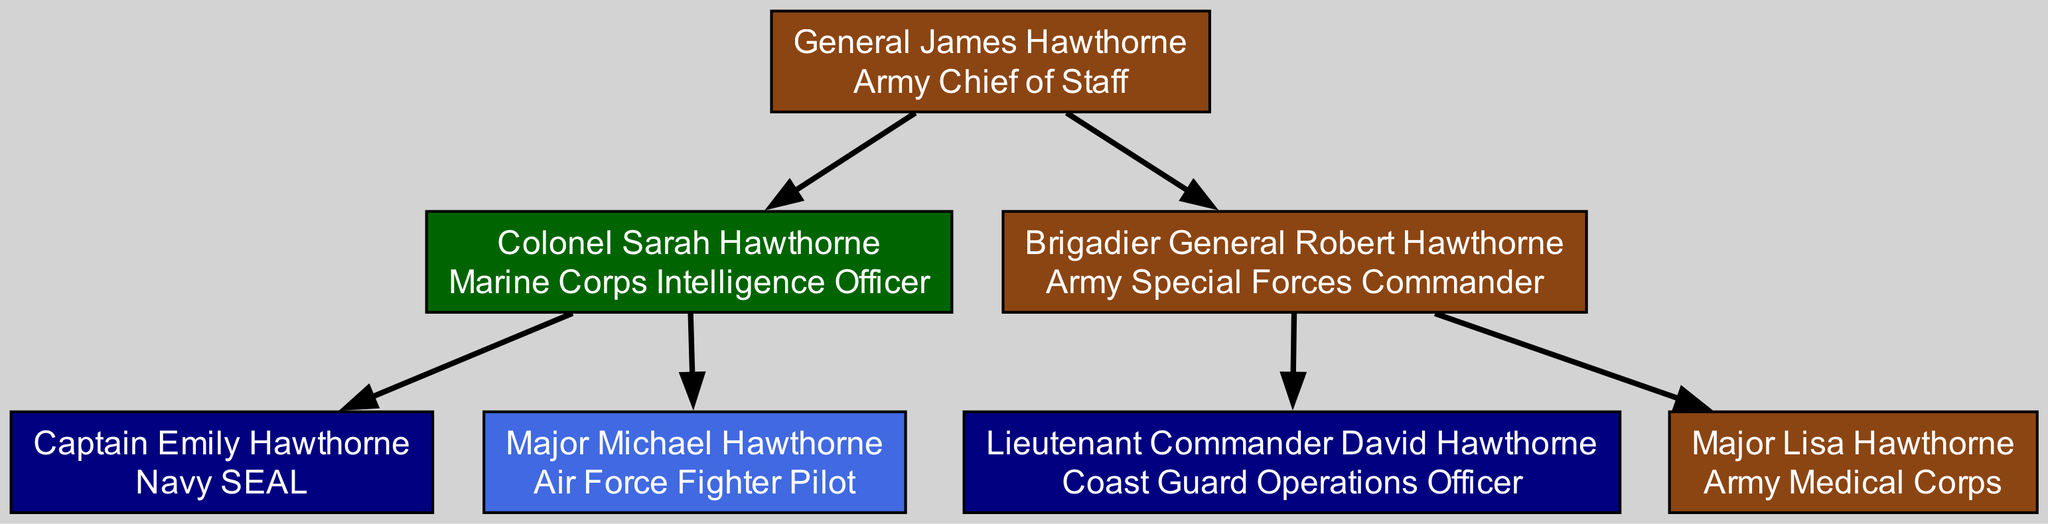What is the role of General James Hawthorne? According to the diagram, General James Hawthorne is designated as the Army Chief of Staff. This is found directly under his name in the root node of the family tree.
Answer: Army Chief of Staff Who is the eldest child of General James Hawthorne? The eldest child listed under General James Hawthorne is Colonel Sarah Hawthorne, as she is the first node in the children array.
Answer: Colonel Sarah Hawthorne How many grandchildren does General James Hawthorne have? There are a total of four grandchildren mentioned under the children of Colonel Sarah Hawthorne and Brigadier General Robert Hawthorne, counted as Captain Emily Hawthorne, Major Michael Hawthorne, Lieutenant Commander David Hawthorne, and Major Lisa Hawthorne.
Answer: Four What military branch does Major Lisa Hawthorne serve in? Major Lisa Hawthorne is associated with the Army Medical Corps, which is part of the Army branch indicated in her role description.
Answer: Army Which branch has more members, the Army or the Navy? In the diagram, there are three Army members (General James, Colonel Sarah, Brigadier General Robert, and Major Lisa) and two Navy members (Captain Emily and Lieutenant Commander David) as per their roles, indicating that the Army has more members.
Answer: Army What is the role of Captain Emily Hawthorne? Captain Emily Hawthorne is specifically noted as a Navy SEAL in the diagram, which is her distinct role associated with the Navy branch.
Answer: Navy SEAL Which of General James Hawthorne's children is a Marine Corps officer? The diagram indicates that Colonel Sarah Hawthorne serves as a Marine Corps Intelligence Officer, which is identified directly under her name.
Answer: Colonel Sarah Hawthorne How many total nodes are present in the family tree? The total number of nodes consists of one root node (General James), two children nodes (Sarah and Robert), and four grandchild nodes (Emily, Michael, David, and Lisa), totaling seven nodes in the family tree.
Answer: Seven 